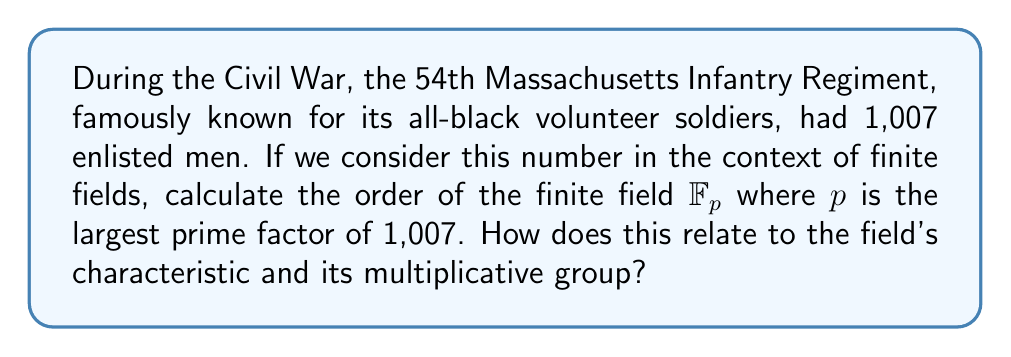Can you solve this math problem? Let's approach this step-by-step:

1) First, we need to factor 1,007:
   $1,007 = 19 \times 53$

2) The largest prime factor is 53.

3) Therefore, we are working with the finite field $\mathbb{F}_{53}$.

4) In a finite field $\mathbb{F}_p$ where $p$ is prime:
   - The order of the field is equal to $p$.
   - The characteristic of the field is also $p$.
   - The multiplicative group $\mathbb{F}_p^*$ has order $p-1$.

5) For $\mathbb{F}_{53}$:
   - The order of the field is 53.
   - The characteristic of the field is 53.
   - The order of the multiplicative group $\mathbb{F}_{53}^*$ is $53-1 = 52$.

6) The relationship between these values:
   - The order of the field ($53$) is one more than the order of its multiplicative group ($52$).
   - The characteristic of the field is equal to its order.

This connects the Civil War regiment number to fundamental properties of finite fields, bridging American history with abstract algebra.
Answer: $53$; characteristic $= 53$, $|\mathbb{F}_{53}^*| = 52$ 